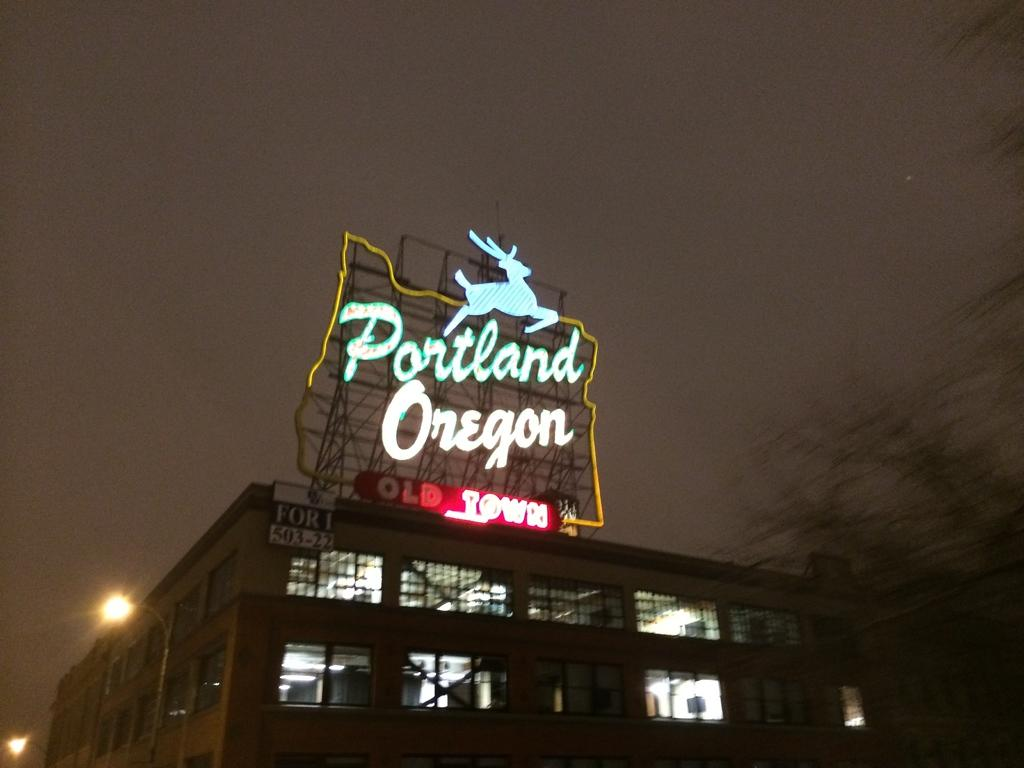What type of structure can be seen in the image? There is a building in the image. What are the vertical structures with wires on them in the image? There are street poles in the image. What are the illuminating devices attached to the street poles? There are street lights in the image. What type of vegetation is present in the image? There are trees in the image. What sign is visible in the image? There is a name board in the image. What is visible in the top part of the image? The sky is visible in the image. How does the building grow in the image? Buildings do not grow like living organisms; they are constructed by humans. Can you see the cannon being fired in the image? There is no cannon present in the image. 